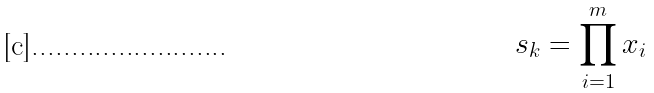Convert formula to latex. <formula><loc_0><loc_0><loc_500><loc_500>s _ { k } = \prod _ { i = 1 } ^ { m } x _ { i }</formula> 